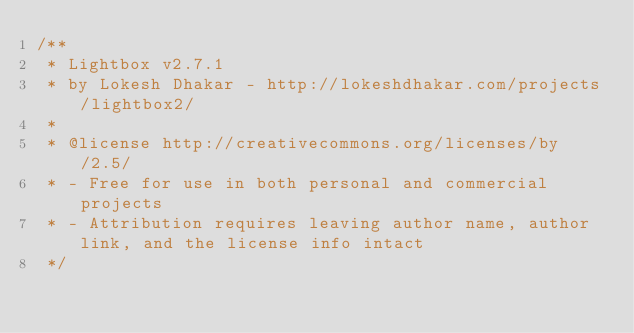<code> <loc_0><loc_0><loc_500><loc_500><_JavaScript_>/**
 * Lightbox v2.7.1
 * by Lokesh Dhakar - http://lokeshdhakar.com/projects/lightbox2/
 *
 * @license http://creativecommons.org/licenses/by/2.5/
 * - Free for use in both personal and commercial projects
 * - Attribution requires leaving author name, author link, and the license info intact
 */</code> 